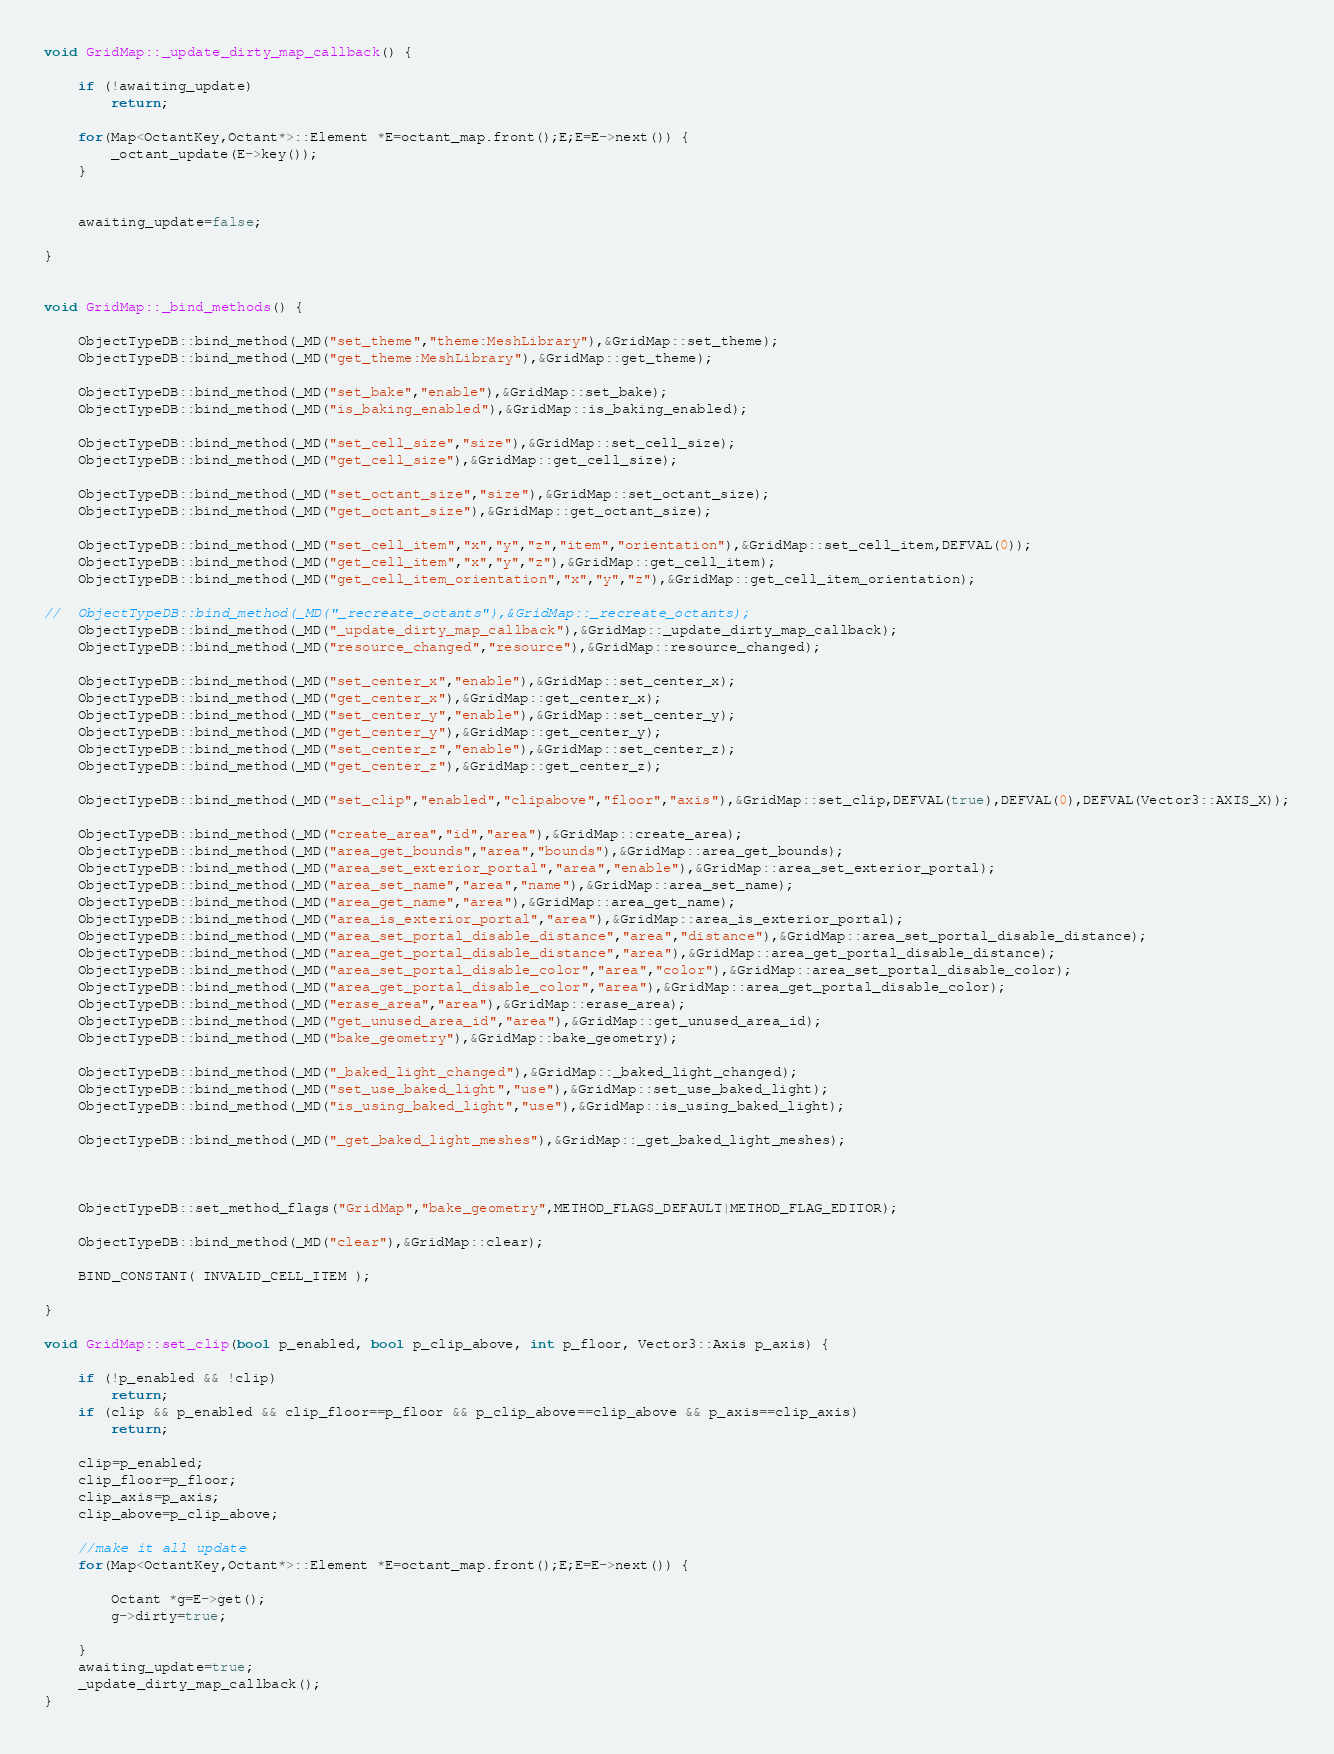<code> <loc_0><loc_0><loc_500><loc_500><_C++_>

void GridMap::_update_dirty_map_callback() {

	if (!awaiting_update)
		return;

	for(Map<OctantKey,Octant*>::Element *E=octant_map.front();E;E=E->next()) {
		_octant_update(E->key());
	}


	awaiting_update=false;

}


void GridMap::_bind_methods() {

	ObjectTypeDB::bind_method(_MD("set_theme","theme:MeshLibrary"),&GridMap::set_theme);
	ObjectTypeDB::bind_method(_MD("get_theme:MeshLibrary"),&GridMap::get_theme);

	ObjectTypeDB::bind_method(_MD("set_bake","enable"),&GridMap::set_bake);
	ObjectTypeDB::bind_method(_MD("is_baking_enabled"),&GridMap::is_baking_enabled);

	ObjectTypeDB::bind_method(_MD("set_cell_size","size"),&GridMap::set_cell_size);
	ObjectTypeDB::bind_method(_MD("get_cell_size"),&GridMap::get_cell_size);

	ObjectTypeDB::bind_method(_MD("set_octant_size","size"),&GridMap::set_octant_size);
	ObjectTypeDB::bind_method(_MD("get_octant_size"),&GridMap::get_octant_size);

	ObjectTypeDB::bind_method(_MD("set_cell_item","x","y","z","item","orientation"),&GridMap::set_cell_item,DEFVAL(0));
	ObjectTypeDB::bind_method(_MD("get_cell_item","x","y","z"),&GridMap::get_cell_item);
	ObjectTypeDB::bind_method(_MD("get_cell_item_orientation","x","y","z"),&GridMap::get_cell_item_orientation);

//	ObjectTypeDB::bind_method(_MD("_recreate_octants"),&GridMap::_recreate_octants);
	ObjectTypeDB::bind_method(_MD("_update_dirty_map_callback"),&GridMap::_update_dirty_map_callback);
	ObjectTypeDB::bind_method(_MD("resource_changed","resource"),&GridMap::resource_changed);

	ObjectTypeDB::bind_method(_MD("set_center_x","enable"),&GridMap::set_center_x);
	ObjectTypeDB::bind_method(_MD("get_center_x"),&GridMap::get_center_x);
	ObjectTypeDB::bind_method(_MD("set_center_y","enable"),&GridMap::set_center_y);
	ObjectTypeDB::bind_method(_MD("get_center_y"),&GridMap::get_center_y);
	ObjectTypeDB::bind_method(_MD("set_center_z","enable"),&GridMap::set_center_z);
	ObjectTypeDB::bind_method(_MD("get_center_z"),&GridMap::get_center_z);

	ObjectTypeDB::bind_method(_MD("set_clip","enabled","clipabove","floor","axis"),&GridMap::set_clip,DEFVAL(true),DEFVAL(0),DEFVAL(Vector3::AXIS_X));

	ObjectTypeDB::bind_method(_MD("create_area","id","area"),&GridMap::create_area);
	ObjectTypeDB::bind_method(_MD("area_get_bounds","area","bounds"),&GridMap::area_get_bounds);
	ObjectTypeDB::bind_method(_MD("area_set_exterior_portal","area","enable"),&GridMap::area_set_exterior_portal);
	ObjectTypeDB::bind_method(_MD("area_set_name","area","name"),&GridMap::area_set_name);
	ObjectTypeDB::bind_method(_MD("area_get_name","area"),&GridMap::area_get_name);
	ObjectTypeDB::bind_method(_MD("area_is_exterior_portal","area"),&GridMap::area_is_exterior_portal);
	ObjectTypeDB::bind_method(_MD("area_set_portal_disable_distance","area","distance"),&GridMap::area_set_portal_disable_distance);
	ObjectTypeDB::bind_method(_MD("area_get_portal_disable_distance","area"),&GridMap::area_get_portal_disable_distance);
	ObjectTypeDB::bind_method(_MD("area_set_portal_disable_color","area","color"),&GridMap::area_set_portal_disable_color);
	ObjectTypeDB::bind_method(_MD("area_get_portal_disable_color","area"),&GridMap::area_get_portal_disable_color);
	ObjectTypeDB::bind_method(_MD("erase_area","area"),&GridMap::erase_area);
	ObjectTypeDB::bind_method(_MD("get_unused_area_id","area"),&GridMap::get_unused_area_id);
	ObjectTypeDB::bind_method(_MD("bake_geometry"),&GridMap::bake_geometry);

	ObjectTypeDB::bind_method(_MD("_baked_light_changed"),&GridMap::_baked_light_changed);
	ObjectTypeDB::bind_method(_MD("set_use_baked_light","use"),&GridMap::set_use_baked_light);
	ObjectTypeDB::bind_method(_MD("is_using_baked_light","use"),&GridMap::is_using_baked_light);

	ObjectTypeDB::bind_method(_MD("_get_baked_light_meshes"),&GridMap::_get_baked_light_meshes);



	ObjectTypeDB::set_method_flags("GridMap","bake_geometry",METHOD_FLAGS_DEFAULT|METHOD_FLAG_EDITOR);

	ObjectTypeDB::bind_method(_MD("clear"),&GridMap::clear);

	BIND_CONSTANT( INVALID_CELL_ITEM );

}

void GridMap::set_clip(bool p_enabled, bool p_clip_above, int p_floor, Vector3::Axis p_axis) {

	if (!p_enabled && !clip)
		return;
	if (clip && p_enabled && clip_floor==p_floor && p_clip_above==clip_above && p_axis==clip_axis)
		return;

	clip=p_enabled;
	clip_floor=p_floor;
	clip_axis=p_axis;
	clip_above=p_clip_above;

	//make it all update
	for(Map<OctantKey,Octant*>::Element *E=octant_map.front();E;E=E->next()) {

		Octant *g=E->get();
		g->dirty=true;

	}
	awaiting_update=true;
	_update_dirty_map_callback();
}

</code> 